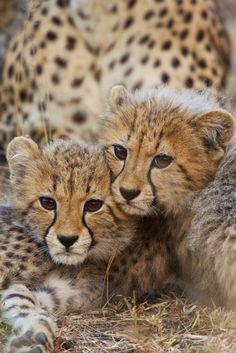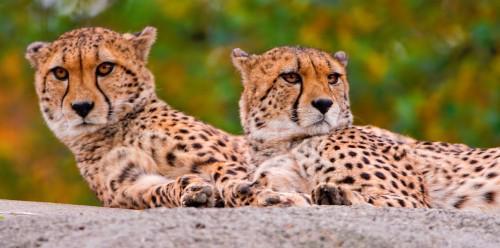The first image is the image on the left, the second image is the image on the right. Assess this claim about the two images: "All of the cheetahs are laying down.". Correct or not? Answer yes or no. Yes. The first image is the image on the left, the second image is the image on the right. Examine the images to the left and right. Is the description "There are a pair of cheetahs laying on the grown while one is grooming the other." accurate? Answer yes or no. No. 